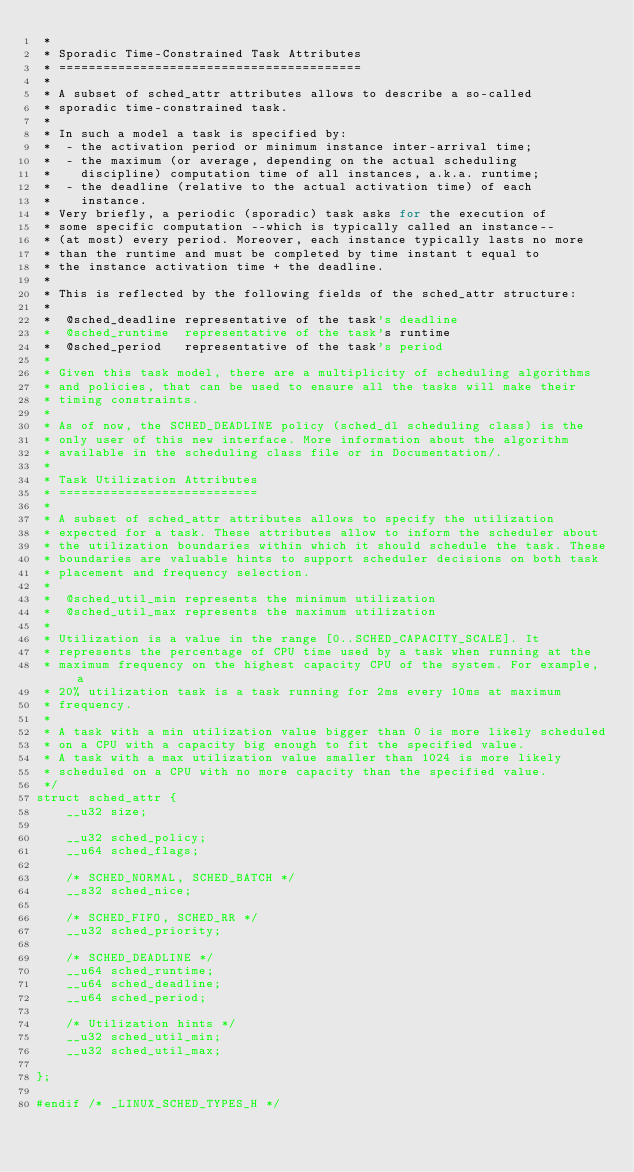Convert code to text. <code><loc_0><loc_0><loc_500><loc_500><_C_> *
 * Sporadic Time-Constrained Task Attributes
 * =========================================
 *
 * A subset of sched_attr attributes allows to describe a so-called
 * sporadic time-constrained task.
 *
 * In such a model a task is specified by:
 *  - the activation period or minimum instance inter-arrival time;
 *  - the maximum (or average, depending on the actual scheduling
 *    discipline) computation time of all instances, a.k.a. runtime;
 *  - the deadline (relative to the actual activation time) of each
 *    instance.
 * Very briefly, a periodic (sporadic) task asks for the execution of
 * some specific computation --which is typically called an instance--
 * (at most) every period. Moreover, each instance typically lasts no more
 * than the runtime and must be completed by time instant t equal to
 * the instance activation time + the deadline.
 *
 * This is reflected by the following fields of the sched_attr structure:
 *
 *  @sched_deadline	representative of the task's deadline
 *  @sched_runtime	representative of the task's runtime
 *  @sched_period	representative of the task's period
 *
 * Given this task model, there are a multiplicity of scheduling algorithms
 * and policies, that can be used to ensure all the tasks will make their
 * timing constraints.
 *
 * As of now, the SCHED_DEADLINE policy (sched_dl scheduling class) is the
 * only user of this new interface. More information about the algorithm
 * available in the scheduling class file or in Documentation/.
 *
 * Task Utilization Attributes
 * ===========================
 *
 * A subset of sched_attr attributes allows to specify the utilization
 * expected for a task. These attributes allow to inform the scheduler about
 * the utilization boundaries within which it should schedule the task. These
 * boundaries are valuable hints to support scheduler decisions on both task
 * placement and frequency selection.
 *
 *  @sched_util_min	represents the minimum utilization
 *  @sched_util_max	represents the maximum utilization
 *
 * Utilization is a value in the range [0..SCHED_CAPACITY_SCALE]. It
 * represents the percentage of CPU time used by a task when running at the
 * maximum frequency on the highest capacity CPU of the system. For example, a
 * 20% utilization task is a task running for 2ms every 10ms at maximum
 * frequency.
 *
 * A task with a min utilization value bigger than 0 is more likely scheduled
 * on a CPU with a capacity big enough to fit the specified value.
 * A task with a max utilization value smaller than 1024 is more likely
 * scheduled on a CPU with no more capacity than the specified value.
 */
struct sched_attr {
	__u32 size;

	__u32 sched_policy;
	__u64 sched_flags;

	/* SCHED_NORMAL, SCHED_BATCH */
	__s32 sched_nice;

	/* SCHED_FIFO, SCHED_RR */
	__u32 sched_priority;

	/* SCHED_DEADLINE */
	__u64 sched_runtime;
	__u64 sched_deadline;
	__u64 sched_period;

	/* Utilization hints */
	__u32 sched_util_min;
	__u32 sched_util_max;

};

#endif /* _LINUX_SCHED_TYPES_H */
</code> 